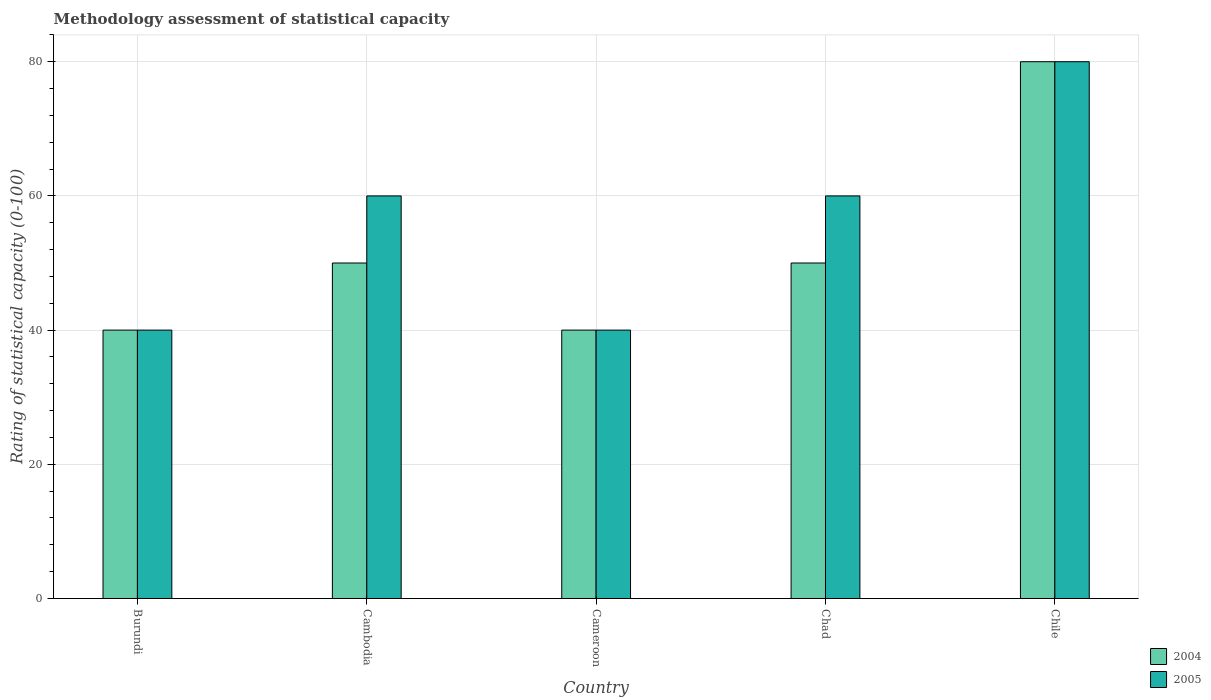How many different coloured bars are there?
Your response must be concise. 2. Are the number of bars per tick equal to the number of legend labels?
Offer a terse response. Yes. How many bars are there on the 4th tick from the left?
Keep it short and to the point. 2. How many bars are there on the 3rd tick from the right?
Provide a short and direct response. 2. What is the label of the 1st group of bars from the left?
Ensure brevity in your answer.  Burundi. In which country was the rating of statistical capacity in 2005 minimum?
Ensure brevity in your answer.  Burundi. What is the total rating of statistical capacity in 2005 in the graph?
Offer a very short reply. 280. What is the difference between the rating of statistical capacity in 2004 in Burundi and that in Cambodia?
Your response must be concise. -10. What is the difference between the rating of statistical capacity of/in 2004 and rating of statistical capacity of/in 2005 in Chile?
Your answer should be compact. 0. In how many countries, is the rating of statistical capacity in 2004 greater than 20?
Offer a very short reply. 5. What is the ratio of the rating of statistical capacity in 2004 in Cambodia to that in Cameroon?
Make the answer very short. 1.25. Does the graph contain grids?
Provide a succinct answer. Yes. How are the legend labels stacked?
Provide a succinct answer. Vertical. What is the title of the graph?
Keep it short and to the point. Methodology assessment of statistical capacity. What is the label or title of the X-axis?
Your answer should be very brief. Country. What is the label or title of the Y-axis?
Keep it short and to the point. Rating of statistical capacity (0-100). What is the Rating of statistical capacity (0-100) in 2004 in Burundi?
Offer a terse response. 40. What is the Rating of statistical capacity (0-100) of 2005 in Burundi?
Offer a very short reply. 40. What is the Rating of statistical capacity (0-100) in 2004 in Cambodia?
Your answer should be very brief. 50. What is the Rating of statistical capacity (0-100) in 2005 in Cambodia?
Provide a short and direct response. 60. What is the Rating of statistical capacity (0-100) in 2004 in Chad?
Give a very brief answer. 50. What is the Rating of statistical capacity (0-100) of 2005 in Chile?
Provide a short and direct response. 80. Across all countries, what is the maximum Rating of statistical capacity (0-100) in 2004?
Offer a very short reply. 80. Across all countries, what is the maximum Rating of statistical capacity (0-100) in 2005?
Your response must be concise. 80. What is the total Rating of statistical capacity (0-100) in 2004 in the graph?
Your answer should be compact. 260. What is the total Rating of statistical capacity (0-100) of 2005 in the graph?
Make the answer very short. 280. What is the difference between the Rating of statistical capacity (0-100) of 2004 in Burundi and that in Cameroon?
Keep it short and to the point. 0. What is the difference between the Rating of statistical capacity (0-100) in 2004 in Burundi and that in Chile?
Give a very brief answer. -40. What is the difference between the Rating of statistical capacity (0-100) of 2005 in Burundi and that in Chile?
Your response must be concise. -40. What is the difference between the Rating of statistical capacity (0-100) in 2004 in Cambodia and that in Chile?
Your answer should be very brief. -30. What is the difference between the Rating of statistical capacity (0-100) in 2005 in Cambodia and that in Chile?
Ensure brevity in your answer.  -20. What is the difference between the Rating of statistical capacity (0-100) in 2004 in Cameroon and that in Chad?
Ensure brevity in your answer.  -10. What is the difference between the Rating of statistical capacity (0-100) of 2005 in Chad and that in Chile?
Provide a succinct answer. -20. What is the difference between the Rating of statistical capacity (0-100) in 2004 in Burundi and the Rating of statistical capacity (0-100) in 2005 in Cambodia?
Offer a terse response. -20. What is the difference between the Rating of statistical capacity (0-100) of 2004 in Burundi and the Rating of statistical capacity (0-100) of 2005 in Chad?
Offer a very short reply. -20. What is the difference between the Rating of statistical capacity (0-100) in 2004 in Cambodia and the Rating of statistical capacity (0-100) in 2005 in Chad?
Your response must be concise. -10. What is the difference between the Rating of statistical capacity (0-100) of 2004 in Cameroon and the Rating of statistical capacity (0-100) of 2005 in Chile?
Your answer should be very brief. -40. What is the difference between the Rating of statistical capacity (0-100) of 2004 in Chad and the Rating of statistical capacity (0-100) of 2005 in Chile?
Keep it short and to the point. -30. What is the average Rating of statistical capacity (0-100) in 2005 per country?
Give a very brief answer. 56. What is the difference between the Rating of statistical capacity (0-100) of 2004 and Rating of statistical capacity (0-100) of 2005 in Chile?
Ensure brevity in your answer.  0. What is the ratio of the Rating of statistical capacity (0-100) of 2004 in Burundi to that in Cameroon?
Offer a very short reply. 1. What is the ratio of the Rating of statistical capacity (0-100) of 2005 in Burundi to that in Chad?
Provide a short and direct response. 0.67. What is the ratio of the Rating of statistical capacity (0-100) of 2004 in Burundi to that in Chile?
Provide a short and direct response. 0.5. What is the ratio of the Rating of statistical capacity (0-100) in 2005 in Burundi to that in Chile?
Your answer should be very brief. 0.5. What is the ratio of the Rating of statistical capacity (0-100) of 2004 in Cambodia to that in Cameroon?
Make the answer very short. 1.25. What is the ratio of the Rating of statistical capacity (0-100) in 2005 in Cambodia to that in Cameroon?
Offer a very short reply. 1.5. What is the ratio of the Rating of statistical capacity (0-100) of 2004 in Cambodia to that in Chad?
Ensure brevity in your answer.  1. What is the ratio of the Rating of statistical capacity (0-100) of 2005 in Cambodia to that in Chile?
Keep it short and to the point. 0.75. What is the ratio of the Rating of statistical capacity (0-100) of 2005 in Cameroon to that in Chad?
Provide a succinct answer. 0.67. What is the ratio of the Rating of statistical capacity (0-100) in 2005 in Cameroon to that in Chile?
Offer a very short reply. 0.5. What is the ratio of the Rating of statistical capacity (0-100) of 2005 in Chad to that in Chile?
Give a very brief answer. 0.75. What is the difference between the highest and the second highest Rating of statistical capacity (0-100) of 2004?
Offer a terse response. 30. What is the difference between the highest and the second highest Rating of statistical capacity (0-100) of 2005?
Your answer should be very brief. 20. What is the difference between the highest and the lowest Rating of statistical capacity (0-100) in 2005?
Your answer should be compact. 40. 